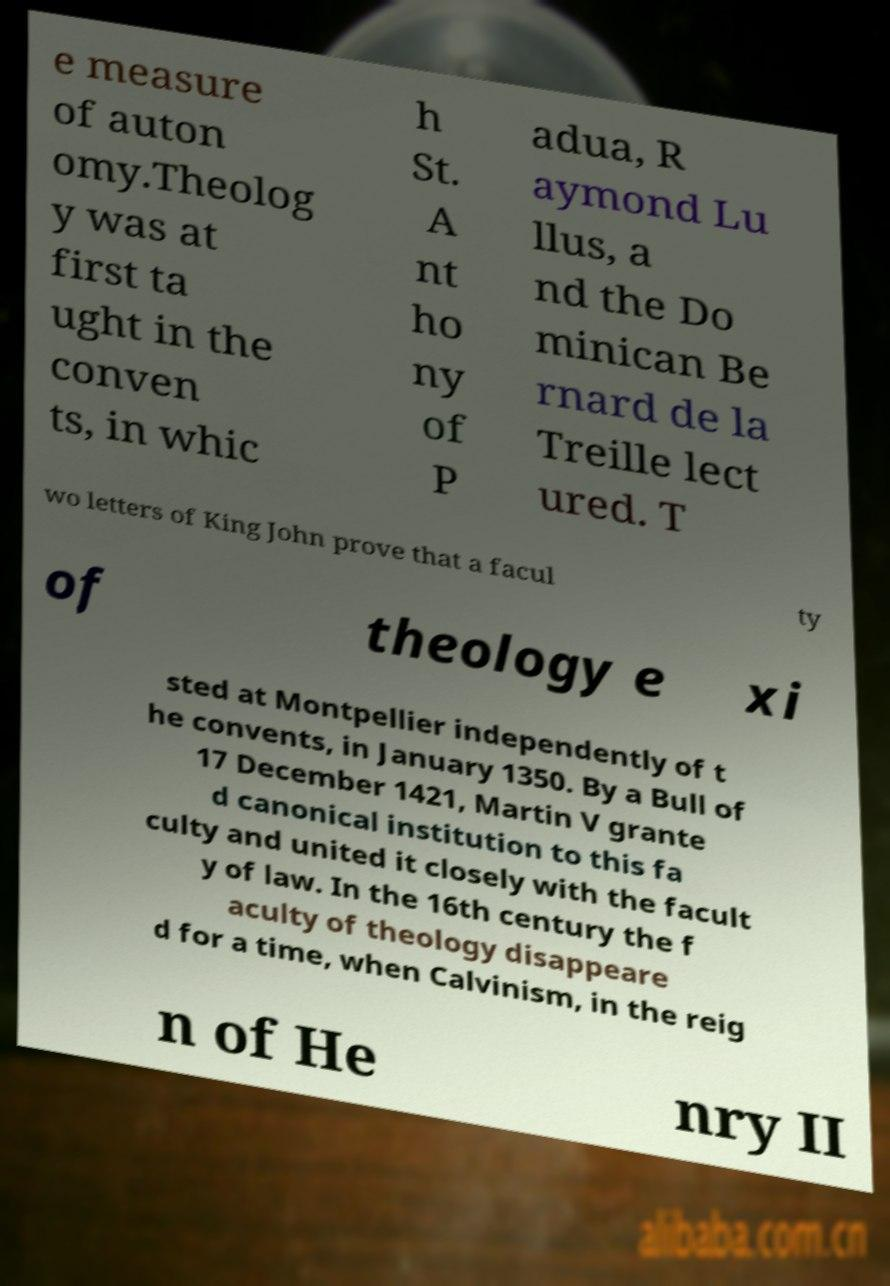Could you assist in decoding the text presented in this image and type it out clearly? e measure of auton omy.Theolog y was at first ta ught in the conven ts, in whic h St. A nt ho ny of P adua, R aymond Lu llus, a nd the Do minican Be rnard de la Treille lect ured. T wo letters of King John prove that a facul ty of theology e xi sted at Montpellier independently of t he convents, in January 1350. By a Bull of 17 December 1421, Martin V grante d canonical institution to this fa culty and united it closely with the facult y of law. In the 16th century the f aculty of theology disappeare d for a time, when Calvinism, in the reig n of He nry II 